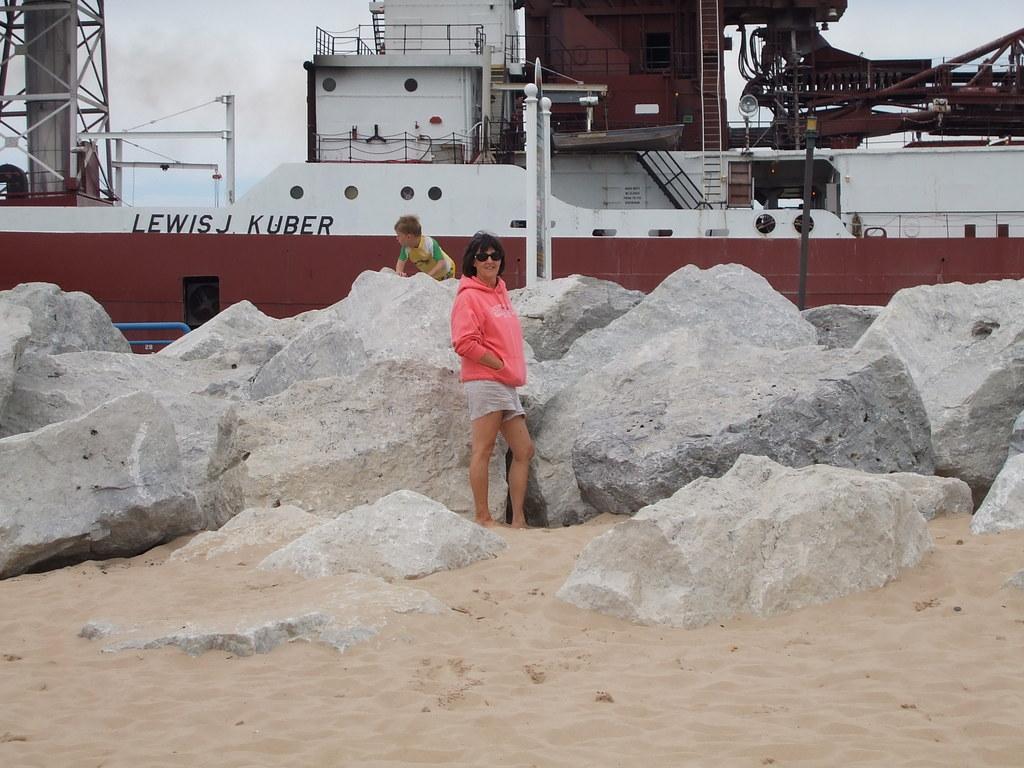Can you describe this image briefly? In this image in the middle, there is a woman, she wears a jacket, trouser, her hair is short, behind that there is a boy. In the middle there are stones and sand. In the background there is a boat and sky. 